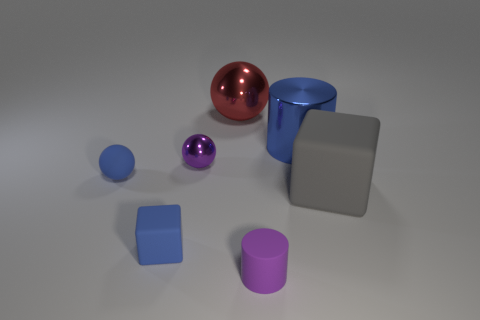There is a purple metallic object that is the same shape as the large red thing; what is its size?
Offer a terse response. Small. Are there more large gray shiny objects than tiny blue rubber objects?
Provide a short and direct response. No. Do the blue metallic thing and the large red thing have the same shape?
Make the answer very short. No. What material is the cylinder in front of the metallic ball in front of the big blue cylinder?
Your answer should be very brief. Rubber. There is a object that is the same color as the small matte cylinder; what material is it?
Provide a succinct answer. Metal. Do the blue cylinder and the blue block have the same size?
Your response must be concise. No. Is there a blue rubber sphere that is right of the blue rubber thing in front of the big block?
Provide a succinct answer. No. There is a metallic object that is the same color as the tiny block; what is its size?
Provide a short and direct response. Large. There is a small matte thing behind the tiny blue rubber cube; what shape is it?
Offer a terse response. Sphere. There is a tiny matte thing on the right side of the block to the left of the large metallic cylinder; how many matte spheres are to the right of it?
Your answer should be very brief. 0. 